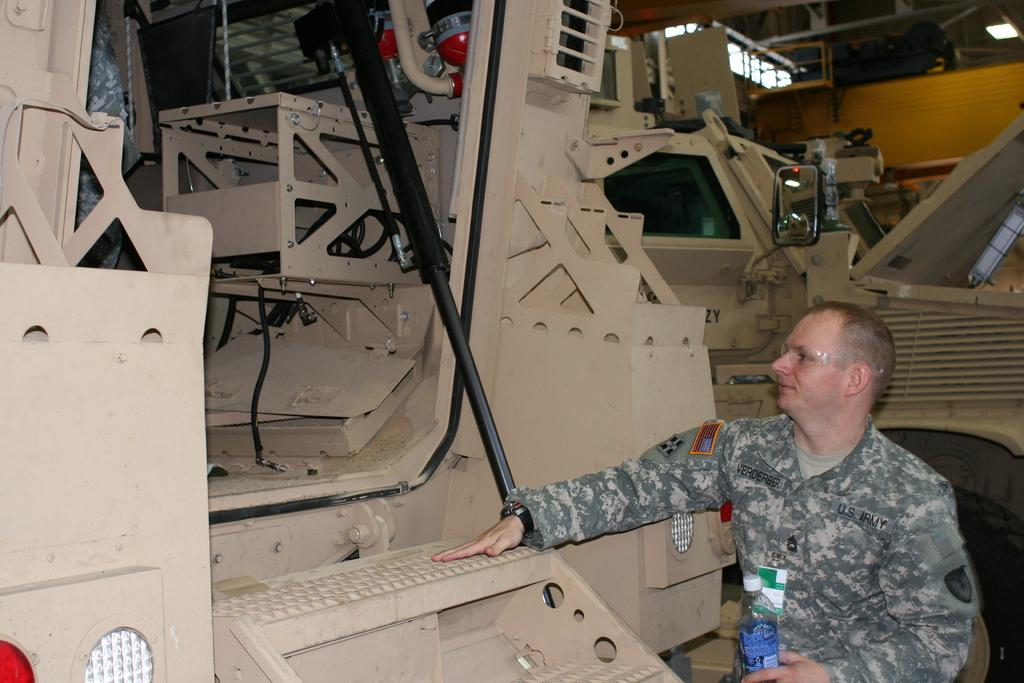What can be seen in the image? There is a person in the image. Can you describe the person's appearance? The person is wearing a uniform and glasses. What is the person holding in the image? The person is holding a bottle. What can be seen in the background of the image? There are machines, a light, and a mirror visible in the background. How many cows are visible in the mirror in the image? There are no cows present in the image, and therefore none can be seen in the mirror. What type of needle is being used by the person in the image? There is no needle present in the image; the person is holding a bottle. 